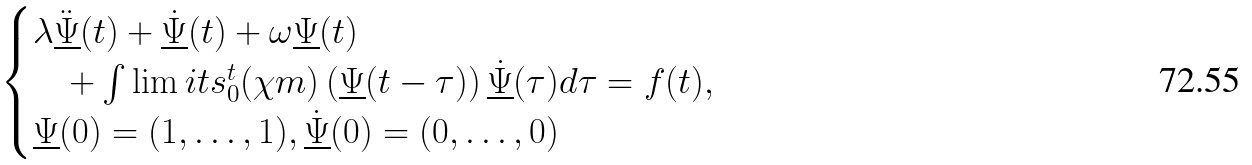Convert formula to latex. <formula><loc_0><loc_0><loc_500><loc_500>\begin{cases} \lambda \ddot { \underline { \Psi } } ( t ) + \dot { \underline { \Psi } } ( t ) + \omega \underline { \Psi } ( t ) \\ \quad + \int \lim i t s _ { 0 } ^ { t } ( \chi m ) \left ( \underline { \Psi } ( t - \tau ) \right ) \dot { \underline { \Psi } } ( \tau ) d \tau = f ( t ) , \\ \underline { \Psi } ( 0 ) = ( 1 , \dots , 1 ) , \underline { \dot { \Psi } } ( 0 ) = ( 0 , \dots , 0 ) \end{cases}</formula> 